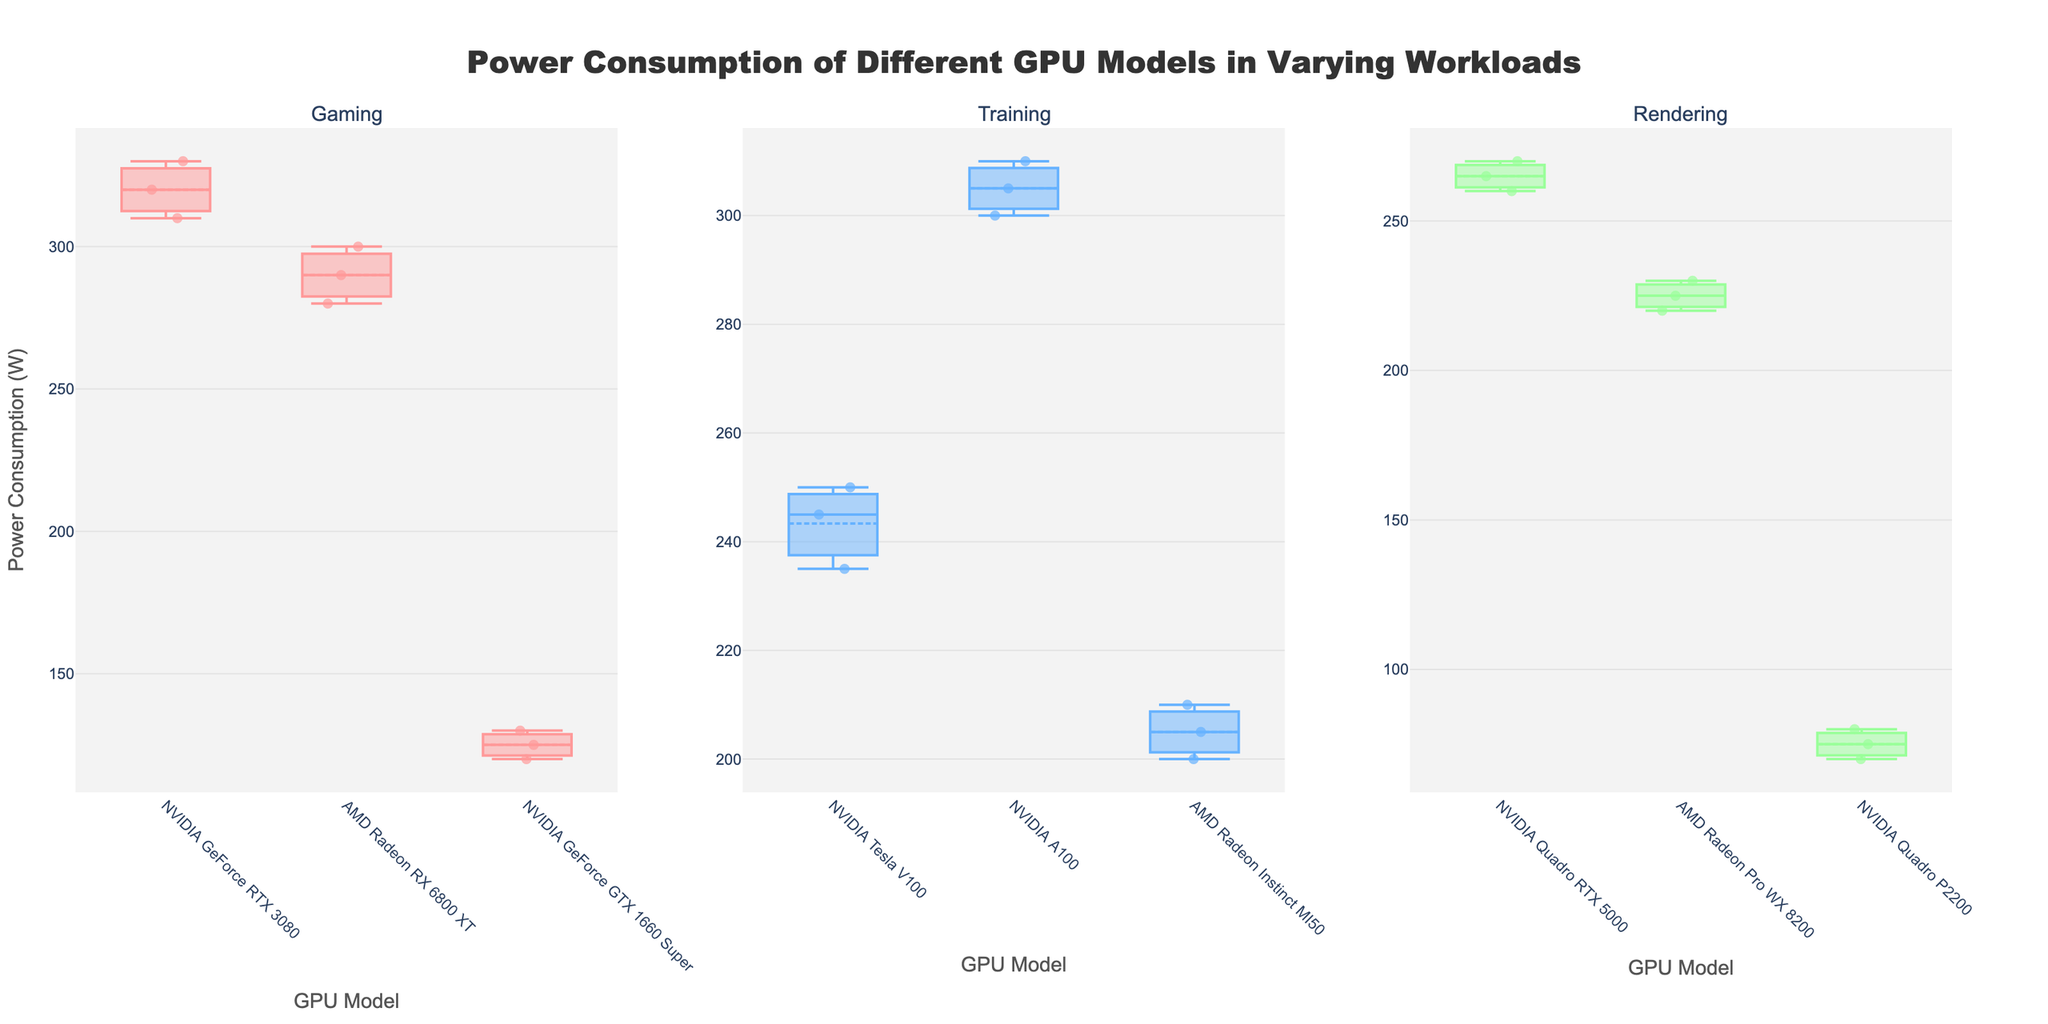What are the three types of workloads shown in the figure? The figure is divided into three subplots, each titled with a different workload. The subplot titles list the workloads.
Answer: Gaming, Training, Rendering Which GPU model has the highest power consumption in the Gaming workload? Look at the box plot corresponding to the Gaming workload. Identify the highest value, which is 330 W. This value corresponds to the NVIDIA GeForce RTX 3080.
Answer: NVIDIA GeForce RTX 3080 Among the GPU models used for Training, which one has the lowest median power consumption? Check the box plots in the Training workload subplot. The AMD Radeon Instinct MI50 has the lowest median value, as it's the bottom-most box plot in this set.
Answer: AMD Radeon Instinct MI50 What is the range of power consumption for the NVIDIA Quadro RTX 5000 during Rendering? The range is determined by the minimum and maximum values indicated by the box plot's whiskers for the NVIDIA Quadro RTX 5000. Those values are 260 W and 270 W.
Answer: 260 W to 270 W Which workload has the widest spread in power consumption for all its GPU models? The spread in each workload can be identified by the range between the highest and lowest points in each subplot's y-axis. The Gaming workload shows the widest spread from about 120 W to 330 W.
Answer: Gaming How does the power consumption of the AMD Radeon RX 6800 XT in Gaming compare to the NVIDIA GeForce RTX 3080? Compare the box plots for both models under the Gaming workload. The AMD Radeon RX 6800 XT ranges from 280 W to 300 W, whereas the NVIDIA GeForce RTX 3080 ranges from 310 W to 330 W. The NVIDIA model consumes more power.
Answer: NVIDIA GeForce RTX 3080 consumes more power Do the average power consumption values for the NVIDIA Tesla V100 and NVIDIA A100 models in Training significantly differ? The average values are indicated by the box mean marker. The NVIDIA Tesla V100 has an average around 243.3 W, while the NVIDIA A100 has an average around 305 W. This shows a significant difference.
Answer: Yes, they significantly differ What is the interquartile range (IQR) for the AMD Radeon Pro WX 8200 during Rendering? The IQR is the range between the first quartile (Q1) and the third quartile (Q3) of the box plot. For the AMD Radeon Pro WX 8200, Q1 is 220 W and Q3 is 230 W. The IQR is 230 W - 220 W.
Answer: 10 W 